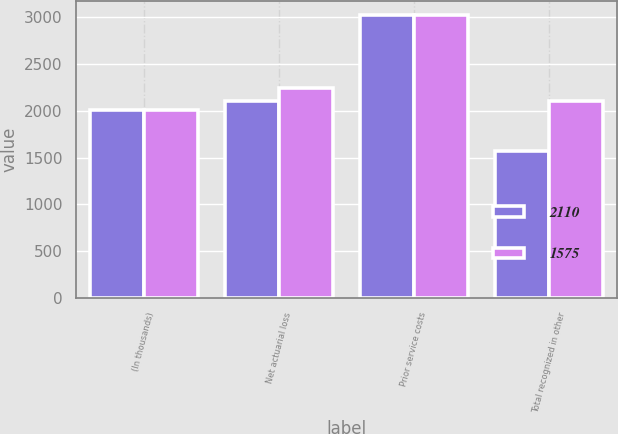Convert chart to OTSL. <chart><loc_0><loc_0><loc_500><loc_500><stacked_bar_chart><ecel><fcel>(In thousands)<fcel>Net actuarial loss<fcel>Prior service costs<fcel>Total recognized in other<nl><fcel>2110<fcel>2012<fcel>2110<fcel>3023<fcel>1575<nl><fcel>1575<fcel>2011<fcel>2243<fcel>3023<fcel>2110<nl></chart> 